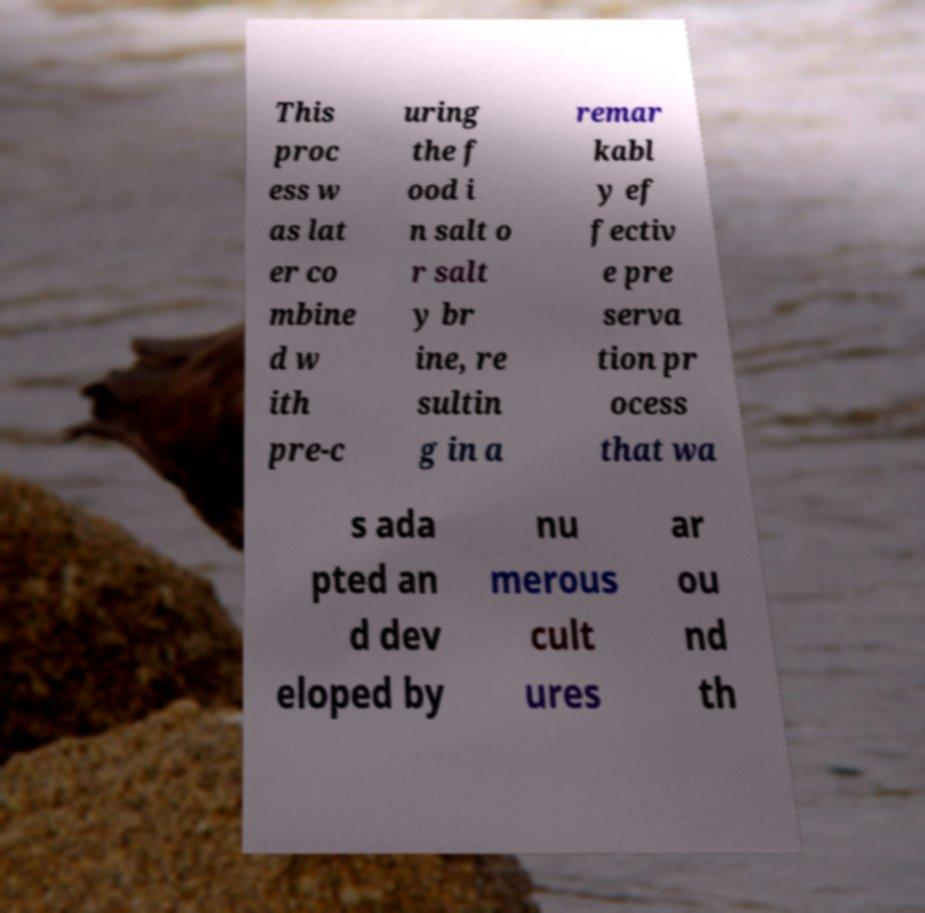Can you read and provide the text displayed in the image?This photo seems to have some interesting text. Can you extract and type it out for me? This proc ess w as lat er co mbine d w ith pre-c uring the f ood i n salt o r salt y br ine, re sultin g in a remar kabl y ef fectiv e pre serva tion pr ocess that wa s ada pted an d dev eloped by nu merous cult ures ar ou nd th 